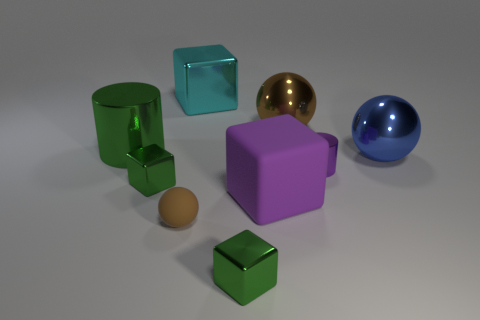What is the color of the other rubber object that is the same shape as the cyan thing?
Make the answer very short. Purple. Is there any other thing that has the same shape as the big brown object?
Offer a terse response. Yes. There is a matte object on the right side of the large metallic cube; what shape is it?
Offer a terse response. Cube. How many other small purple objects are the same shape as the tiny matte object?
Your answer should be very brief. 0. There is a big block that is on the left side of the large rubber thing; is its color the same as the tiny matte sphere to the left of the small purple object?
Your answer should be very brief. No. What number of objects are either large brown objects or big purple blocks?
Make the answer very short. 2. How many cubes are the same material as the large brown thing?
Give a very brief answer. 3. Are there fewer big cyan metal blocks than big objects?
Keep it short and to the point. Yes. Is the brown object that is left of the brown metal sphere made of the same material as the large brown ball?
Provide a short and direct response. No. How many cylinders are either small yellow rubber objects or purple metallic things?
Offer a terse response. 1. 